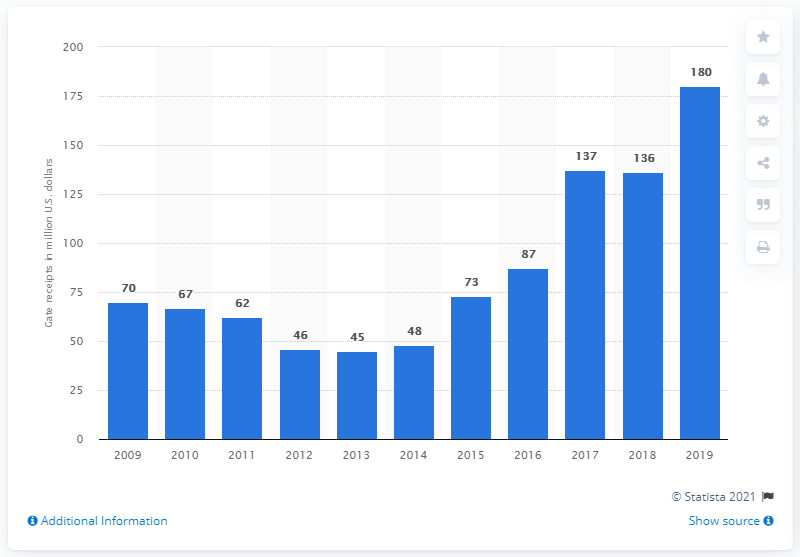Draw attention to some important aspects in this diagram. The Houston Astros reported gate receipts of 180 million dollars in 2019. 